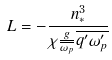<formula> <loc_0><loc_0><loc_500><loc_500>L = - \frac { n _ { * } ^ { 3 } } { \chi \frac { g } { \overline { \omega _ { p } } } \overline { q ^ { \prime } \omega _ { p } ^ { \prime } } }</formula> 